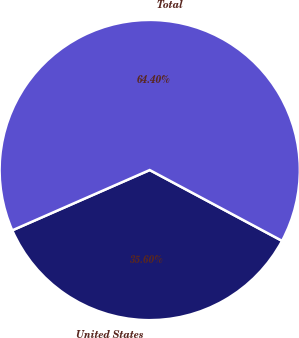Convert chart to OTSL. <chart><loc_0><loc_0><loc_500><loc_500><pie_chart><fcel>United States<fcel>Total<nl><fcel>35.6%<fcel>64.4%<nl></chart> 